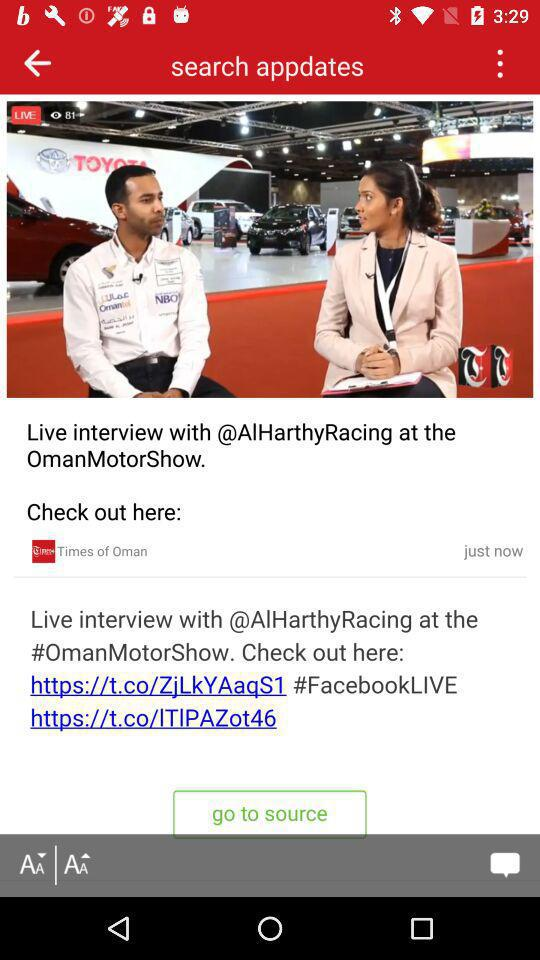What is the newspaper name? The newspaper name is "Times of Oman". 